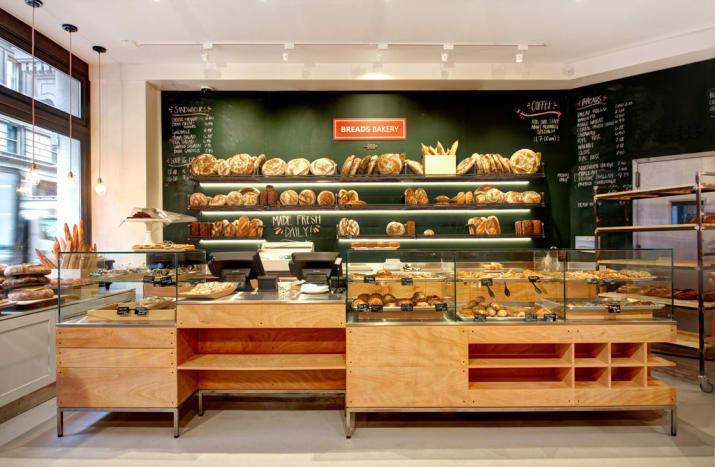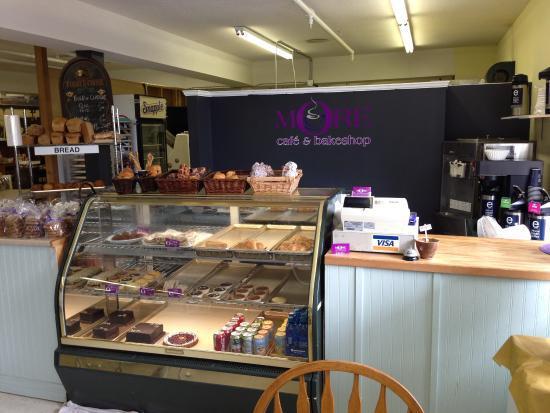The first image is the image on the left, the second image is the image on the right. For the images displayed, is the sentence "In one image, dark wall-mounted menu boards have items listed in white writing." factually correct? Answer yes or no. Yes. 